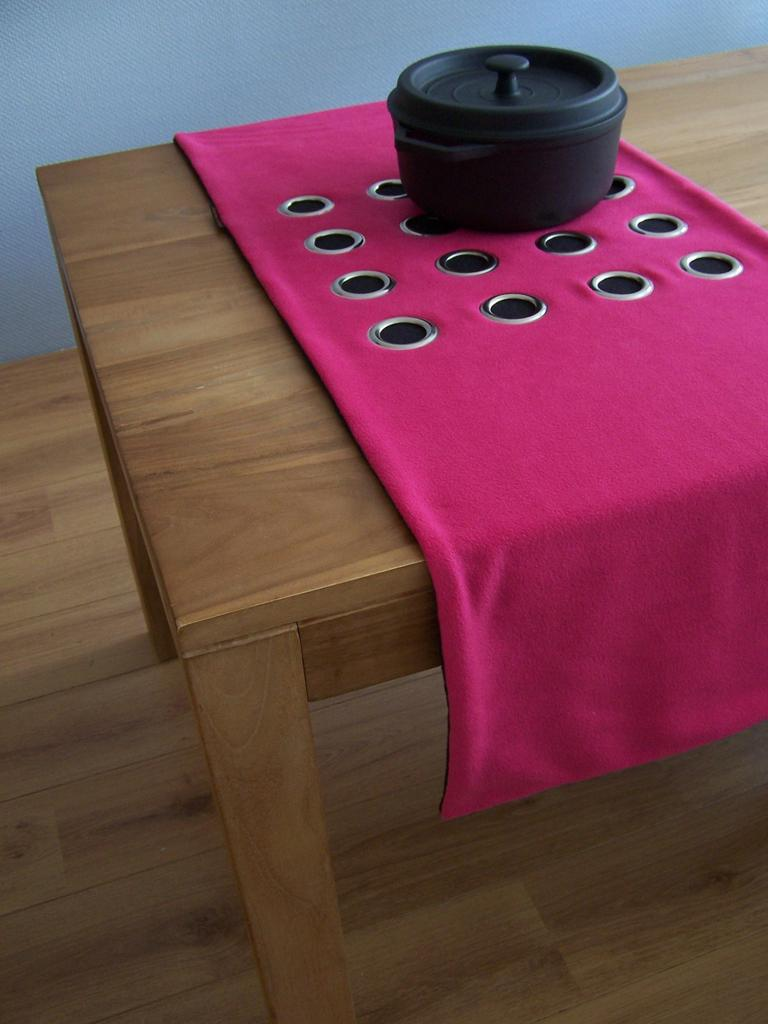What color is the cloth on the table in the image? The cloth on the table is pink. What is the color of the table in the image? The table is brown. What object is placed on the pink cloth? There is a black box on the pink cloth. What can be seen in the background of the image? There is a wall in the background of the image. How many rabbits are sitting on the black box in the image? There are no rabbits present in the image; it only features a pink cloth, a brown table, a black box, and a wall in the background. What type of snail can be seen crawling on the wall in the image? There is no snail present in the image; it only features a pink cloth, a brown table, a black box, and a wall in the background. 